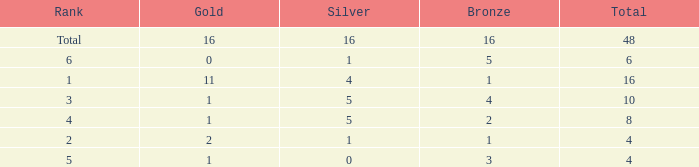How many total gold are less than 4? 0.0. 